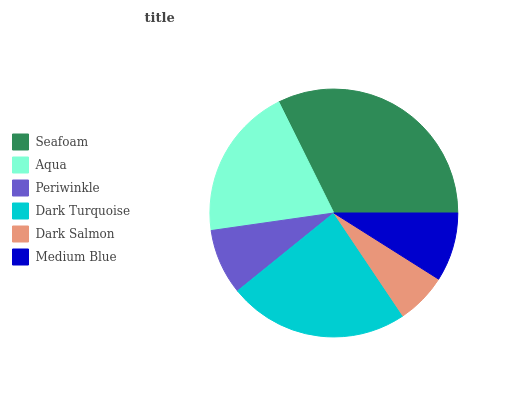Is Dark Salmon the minimum?
Answer yes or no. Yes. Is Seafoam the maximum?
Answer yes or no. Yes. Is Aqua the minimum?
Answer yes or no. No. Is Aqua the maximum?
Answer yes or no. No. Is Seafoam greater than Aqua?
Answer yes or no. Yes. Is Aqua less than Seafoam?
Answer yes or no. Yes. Is Aqua greater than Seafoam?
Answer yes or no. No. Is Seafoam less than Aqua?
Answer yes or no. No. Is Aqua the high median?
Answer yes or no. Yes. Is Medium Blue the low median?
Answer yes or no. Yes. Is Medium Blue the high median?
Answer yes or no. No. Is Seafoam the low median?
Answer yes or no. No. 